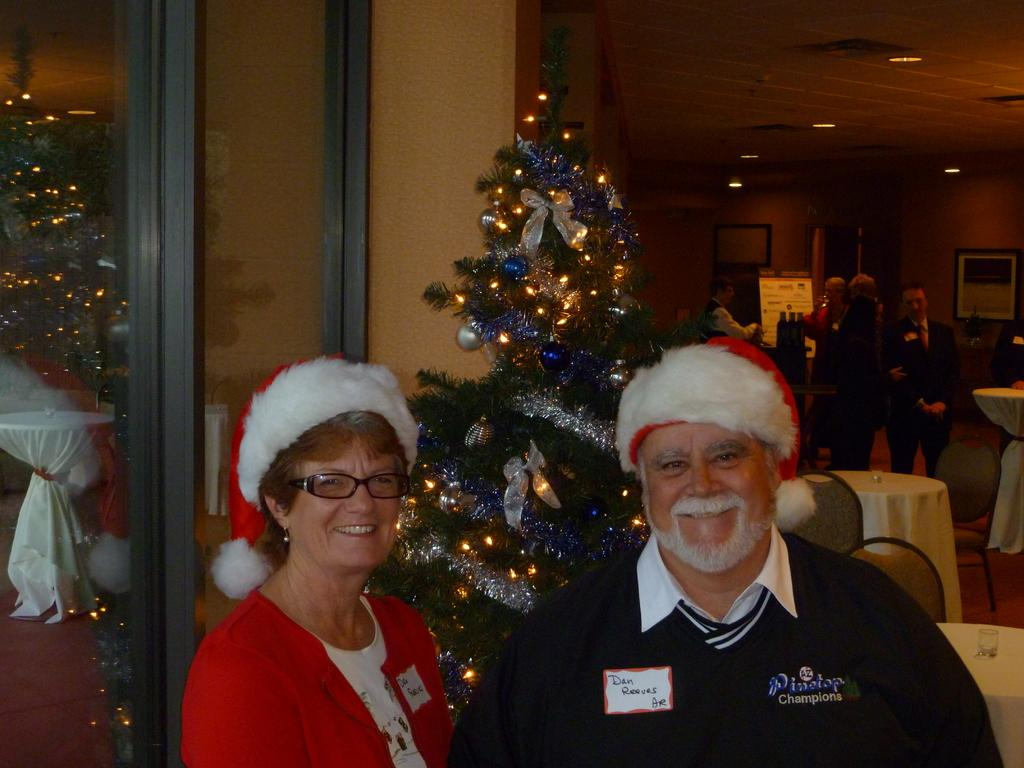Provide a one-sentence caption for the provided image. A woman is standing next to a man wearing a santa hat and a sweater that says Pinetop Champions. 